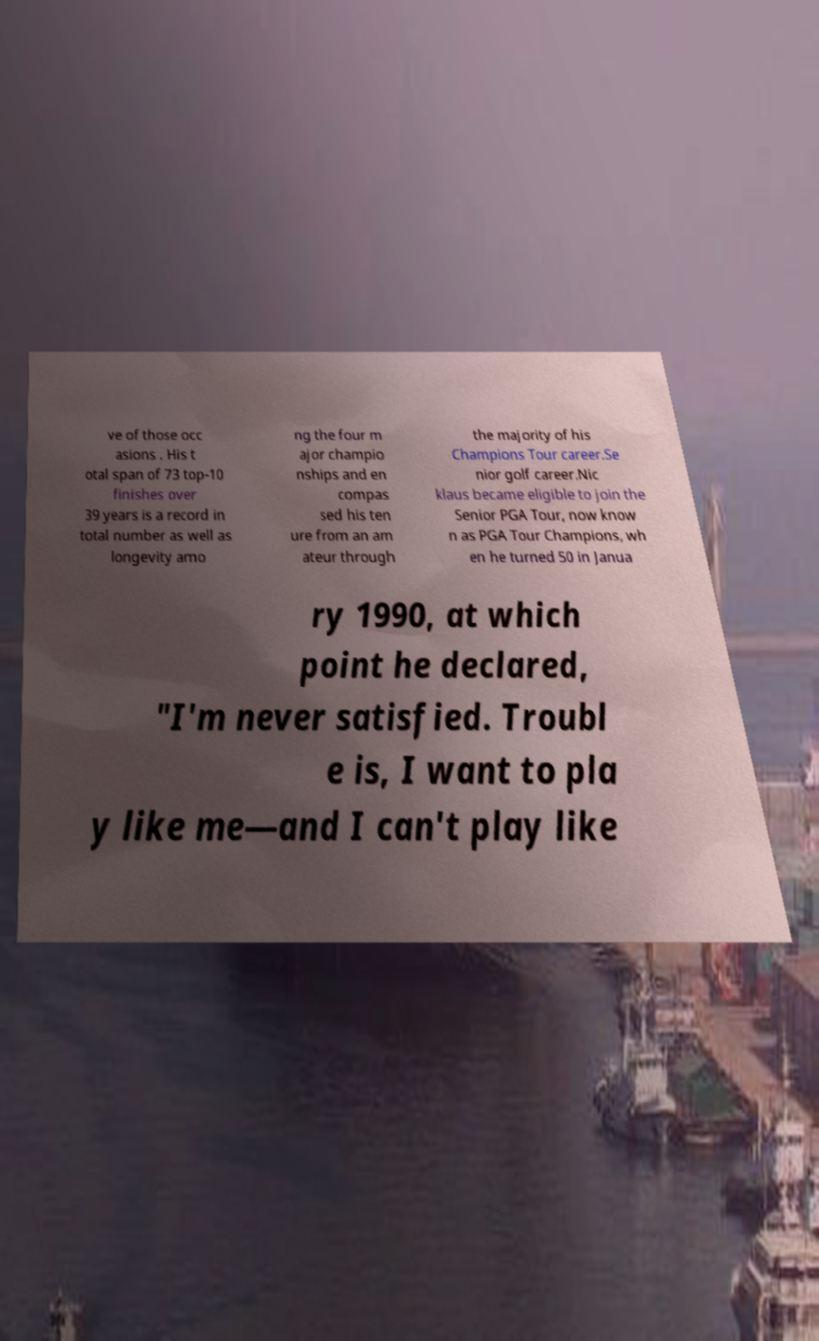I need the written content from this picture converted into text. Can you do that? ve of those occ asions . His t otal span of 73 top-10 finishes over 39 years is a record in total number as well as longevity amo ng the four m ajor champio nships and en compas sed his ten ure from an am ateur through the majority of his Champions Tour career.Se nior golf career.Nic klaus became eligible to join the Senior PGA Tour, now know n as PGA Tour Champions, wh en he turned 50 in Janua ry 1990, at which point he declared, "I'm never satisfied. Troubl e is, I want to pla y like me—and I can't play like 